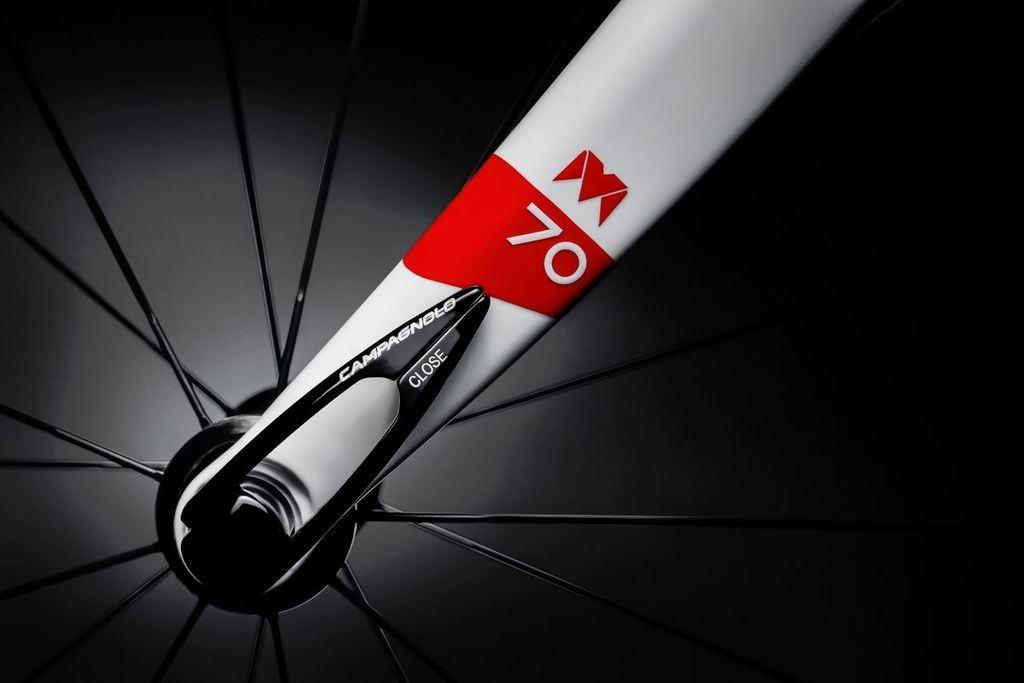How would you summarize this image in a sentence or two? In this image we can see cycle spokes of black color and there is red and white color rod on which something is written. 